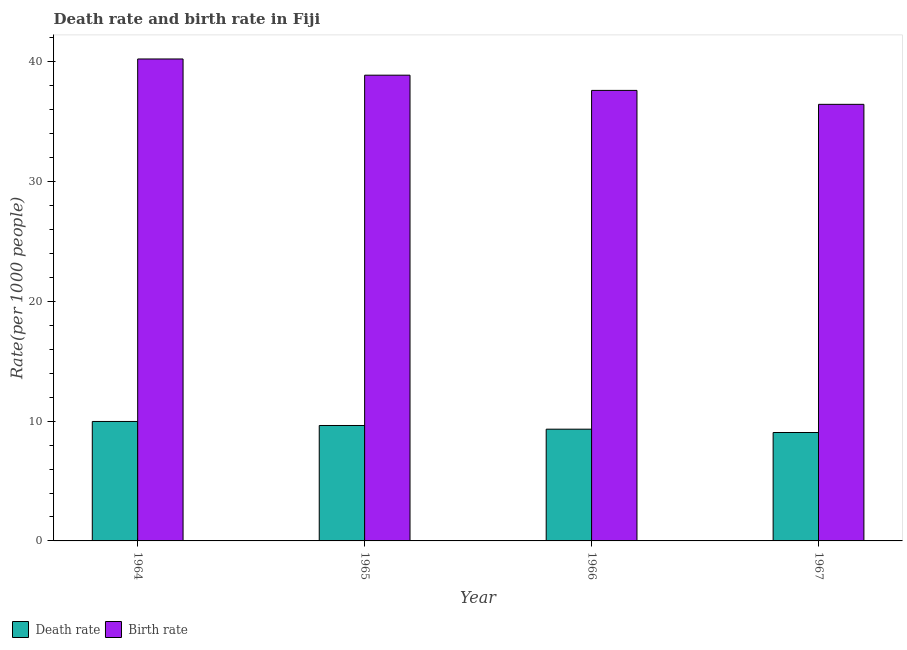How many bars are there on the 3rd tick from the right?
Offer a very short reply. 2. What is the label of the 4th group of bars from the left?
Provide a short and direct response. 1967. In how many cases, is the number of bars for a given year not equal to the number of legend labels?
Your response must be concise. 0. What is the birth rate in 1965?
Your answer should be very brief. 38.89. Across all years, what is the maximum birth rate?
Provide a short and direct response. 40.25. Across all years, what is the minimum death rate?
Your answer should be compact. 9.05. In which year was the death rate maximum?
Ensure brevity in your answer.  1964. In which year was the death rate minimum?
Offer a terse response. 1967. What is the total birth rate in the graph?
Your answer should be compact. 153.22. What is the difference between the birth rate in 1966 and that in 1967?
Provide a short and direct response. 1.16. What is the difference between the death rate in 1965 and the birth rate in 1967?
Your answer should be compact. 0.58. What is the average birth rate per year?
Make the answer very short. 38.31. In how many years, is the death rate greater than 4?
Keep it short and to the point. 4. What is the ratio of the birth rate in 1966 to that in 1967?
Offer a very short reply. 1.03. Is the difference between the birth rate in 1965 and 1966 greater than the difference between the death rate in 1965 and 1966?
Provide a short and direct response. No. What is the difference between the highest and the second highest death rate?
Your answer should be very brief. 0.34. What is the difference between the highest and the lowest birth rate?
Provide a short and direct response. 3.79. What does the 1st bar from the left in 1966 represents?
Your answer should be compact. Death rate. What does the 1st bar from the right in 1967 represents?
Your answer should be very brief. Birth rate. How many bars are there?
Keep it short and to the point. 8. Are all the bars in the graph horizontal?
Your answer should be compact. No. How many years are there in the graph?
Your answer should be very brief. 4. What is the difference between two consecutive major ticks on the Y-axis?
Your response must be concise. 10. Are the values on the major ticks of Y-axis written in scientific E-notation?
Provide a succinct answer. No. Does the graph contain any zero values?
Your answer should be compact. No. Where does the legend appear in the graph?
Offer a very short reply. Bottom left. What is the title of the graph?
Offer a very short reply. Death rate and birth rate in Fiji. Does "Urban" appear as one of the legend labels in the graph?
Provide a succinct answer. No. What is the label or title of the Y-axis?
Offer a very short reply. Rate(per 1000 people). What is the Rate(per 1000 people) of Death rate in 1964?
Give a very brief answer. 9.98. What is the Rate(per 1000 people) of Birth rate in 1964?
Keep it short and to the point. 40.25. What is the Rate(per 1000 people) of Death rate in 1965?
Make the answer very short. 9.64. What is the Rate(per 1000 people) of Birth rate in 1965?
Offer a very short reply. 38.89. What is the Rate(per 1000 people) of Death rate in 1966?
Your response must be concise. 9.33. What is the Rate(per 1000 people) in Birth rate in 1966?
Ensure brevity in your answer.  37.62. What is the Rate(per 1000 people) of Death rate in 1967?
Give a very brief answer. 9.05. What is the Rate(per 1000 people) of Birth rate in 1967?
Offer a terse response. 36.46. Across all years, what is the maximum Rate(per 1000 people) in Death rate?
Your response must be concise. 9.98. Across all years, what is the maximum Rate(per 1000 people) in Birth rate?
Offer a very short reply. 40.25. Across all years, what is the minimum Rate(per 1000 people) of Death rate?
Offer a terse response. 9.05. Across all years, what is the minimum Rate(per 1000 people) in Birth rate?
Your answer should be very brief. 36.46. What is the total Rate(per 1000 people) in Death rate in the graph?
Provide a succinct answer. 38. What is the total Rate(per 1000 people) of Birth rate in the graph?
Offer a very short reply. 153.22. What is the difference between the Rate(per 1000 people) of Death rate in 1964 and that in 1965?
Provide a short and direct response. 0.34. What is the difference between the Rate(per 1000 people) in Birth rate in 1964 and that in 1965?
Give a very brief answer. 1.35. What is the difference between the Rate(per 1000 people) of Death rate in 1964 and that in 1966?
Offer a terse response. 0.65. What is the difference between the Rate(per 1000 people) of Birth rate in 1964 and that in 1966?
Offer a very short reply. 2.62. What is the difference between the Rate(per 1000 people) in Death rate in 1964 and that in 1967?
Keep it short and to the point. 0.92. What is the difference between the Rate(per 1000 people) of Birth rate in 1964 and that in 1967?
Provide a succinct answer. 3.79. What is the difference between the Rate(per 1000 people) of Death rate in 1965 and that in 1966?
Ensure brevity in your answer.  0.31. What is the difference between the Rate(per 1000 people) in Birth rate in 1965 and that in 1966?
Your answer should be very brief. 1.27. What is the difference between the Rate(per 1000 people) of Death rate in 1965 and that in 1967?
Provide a short and direct response. 0.58. What is the difference between the Rate(per 1000 people) of Birth rate in 1965 and that in 1967?
Your answer should be compact. 2.44. What is the difference between the Rate(per 1000 people) of Death rate in 1966 and that in 1967?
Provide a short and direct response. 0.28. What is the difference between the Rate(per 1000 people) in Birth rate in 1966 and that in 1967?
Give a very brief answer. 1.16. What is the difference between the Rate(per 1000 people) of Death rate in 1964 and the Rate(per 1000 people) of Birth rate in 1965?
Provide a succinct answer. -28.92. What is the difference between the Rate(per 1000 people) of Death rate in 1964 and the Rate(per 1000 people) of Birth rate in 1966?
Give a very brief answer. -27.65. What is the difference between the Rate(per 1000 people) in Death rate in 1964 and the Rate(per 1000 people) in Birth rate in 1967?
Provide a short and direct response. -26.48. What is the difference between the Rate(per 1000 people) in Death rate in 1965 and the Rate(per 1000 people) in Birth rate in 1966?
Give a very brief answer. -27.98. What is the difference between the Rate(per 1000 people) in Death rate in 1965 and the Rate(per 1000 people) in Birth rate in 1967?
Offer a terse response. -26.82. What is the difference between the Rate(per 1000 people) in Death rate in 1966 and the Rate(per 1000 people) in Birth rate in 1967?
Keep it short and to the point. -27.13. What is the average Rate(per 1000 people) of Death rate per year?
Offer a terse response. 9.5. What is the average Rate(per 1000 people) in Birth rate per year?
Your answer should be compact. 38.31. In the year 1964, what is the difference between the Rate(per 1000 people) in Death rate and Rate(per 1000 people) in Birth rate?
Provide a succinct answer. -30.27. In the year 1965, what is the difference between the Rate(per 1000 people) of Death rate and Rate(per 1000 people) of Birth rate?
Your answer should be compact. -29.25. In the year 1966, what is the difference between the Rate(per 1000 people) in Death rate and Rate(per 1000 people) in Birth rate?
Provide a short and direct response. -28.29. In the year 1967, what is the difference between the Rate(per 1000 people) in Death rate and Rate(per 1000 people) in Birth rate?
Make the answer very short. -27.41. What is the ratio of the Rate(per 1000 people) of Death rate in 1964 to that in 1965?
Your answer should be compact. 1.03. What is the ratio of the Rate(per 1000 people) of Birth rate in 1964 to that in 1965?
Give a very brief answer. 1.03. What is the ratio of the Rate(per 1000 people) in Death rate in 1964 to that in 1966?
Your answer should be compact. 1.07. What is the ratio of the Rate(per 1000 people) of Birth rate in 1964 to that in 1966?
Provide a succinct answer. 1.07. What is the ratio of the Rate(per 1000 people) of Death rate in 1964 to that in 1967?
Provide a short and direct response. 1.1. What is the ratio of the Rate(per 1000 people) of Birth rate in 1964 to that in 1967?
Provide a succinct answer. 1.1. What is the ratio of the Rate(per 1000 people) in Death rate in 1965 to that in 1966?
Offer a very short reply. 1.03. What is the ratio of the Rate(per 1000 people) in Birth rate in 1965 to that in 1966?
Make the answer very short. 1.03. What is the ratio of the Rate(per 1000 people) in Death rate in 1965 to that in 1967?
Provide a short and direct response. 1.06. What is the ratio of the Rate(per 1000 people) of Birth rate in 1965 to that in 1967?
Your response must be concise. 1.07. What is the ratio of the Rate(per 1000 people) in Death rate in 1966 to that in 1967?
Keep it short and to the point. 1.03. What is the ratio of the Rate(per 1000 people) in Birth rate in 1966 to that in 1967?
Ensure brevity in your answer.  1.03. What is the difference between the highest and the second highest Rate(per 1000 people) of Death rate?
Provide a short and direct response. 0.34. What is the difference between the highest and the second highest Rate(per 1000 people) of Birth rate?
Offer a very short reply. 1.35. What is the difference between the highest and the lowest Rate(per 1000 people) of Death rate?
Your response must be concise. 0.92. What is the difference between the highest and the lowest Rate(per 1000 people) of Birth rate?
Offer a terse response. 3.79. 